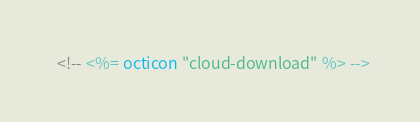Convert code to text. <code><loc_0><loc_0><loc_500><loc_500><_TypeScript_>  <!-- <%= octicon "cloud-download" %> --></code> 